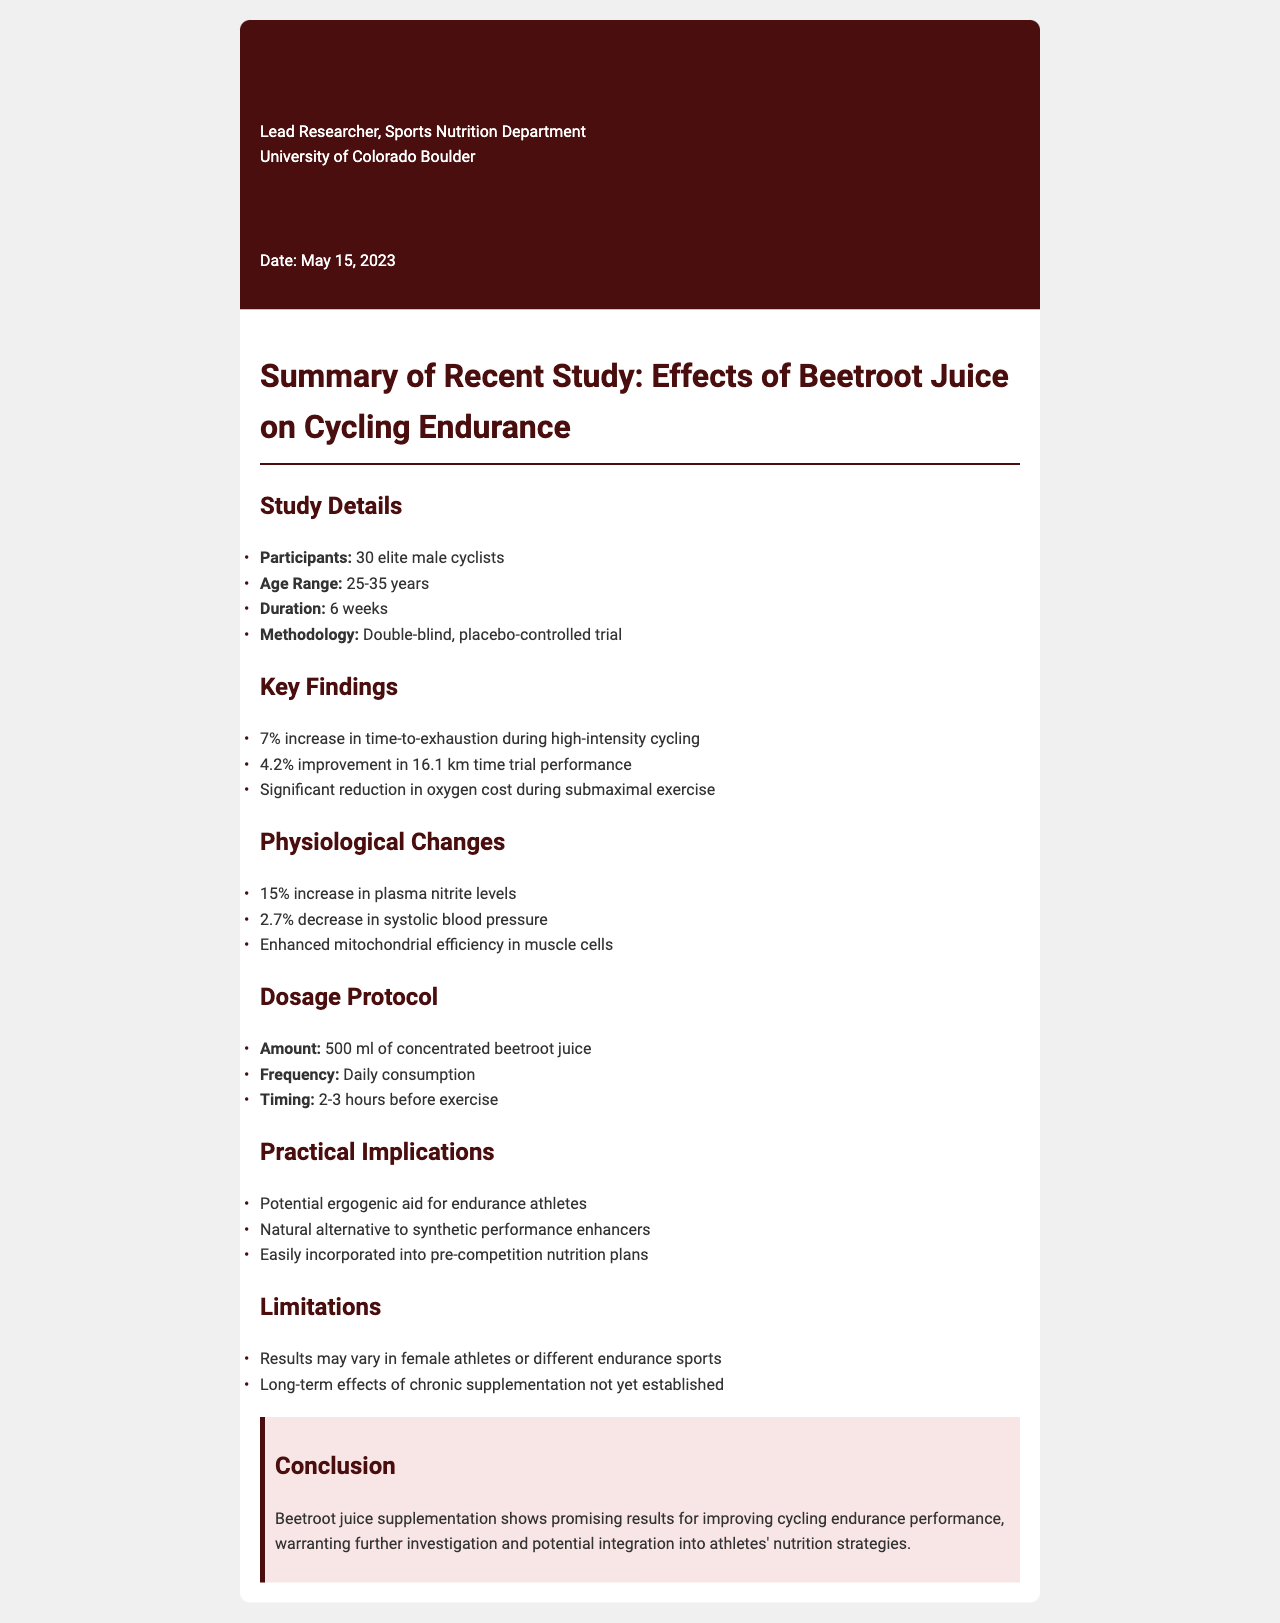What is the age range of participants? The age range of participants is mentioned in the study details section.
Answer: 25-35 years What was the sample size of the study? The sample size, or number of participants in the study, is specified in the study details section.
Answer: 30 elite male cyclists What was the percentage improvement in the time trial performance? The percentage improvement in 16.1 km time trial performance is highlighted in the key findings section.
Answer: 4.2% How much did plasma nitrite levels increase? The increase in plasma nitrite levels is stated in the physiological changes section.
Answer: 15% What is the dosage frequency for beetroot juice? The frequency of beetroot juice consumption is indicated in the dosage protocol section.
Answer: Daily consumption What are the limitations mentioned in the study? The limitations of the study are summarized in their own section and include results in different populations.
Answer: Female athletes or different endurance sports What does the conclusion suggest about beetroot juice? The conclusion summarizes the overall findings and implications of the study regarding beetroot juice.
Answer: Promising results for improving cycling endurance performance 